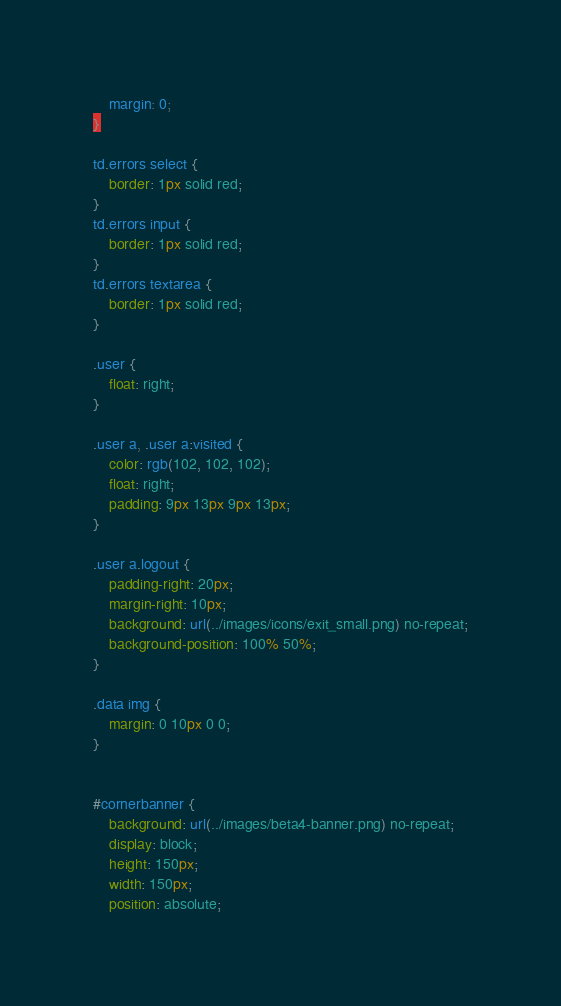Convert code to text. <code><loc_0><loc_0><loc_500><loc_500><_CSS_>    margin: 0;
}

td.errors select {
    border: 1px solid red;
}
td.errors input {
    border: 1px solid red;
}
td.errors textarea {
    border: 1px solid red;
}

.user {
    float: right;
}

.user a, .user a:visited {
    color: rgb(102, 102, 102);
    float: right;
    padding: 9px 13px 9px 13px;
}

.user a.logout {
    padding-right: 20px;
    margin-right: 10px;
    background: url(../images/icons/exit_small.png) no-repeat;
    background-position: 100% 50%;
}

.data img {
    margin: 0 10px 0 0;
}


#cornerbanner {
    background: url(../images/beta4-banner.png) no-repeat;
    display: block;
    height: 150px;
    width: 150px;
    position: absolute;</code> 